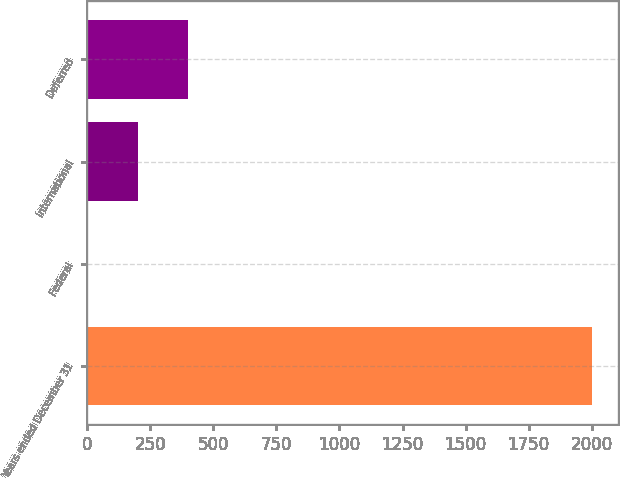<chart> <loc_0><loc_0><loc_500><loc_500><bar_chart><fcel>Years ended December 31<fcel>Federal<fcel>International<fcel>Deferred<nl><fcel>2003<fcel>0.1<fcel>200.39<fcel>400.68<nl></chart> 